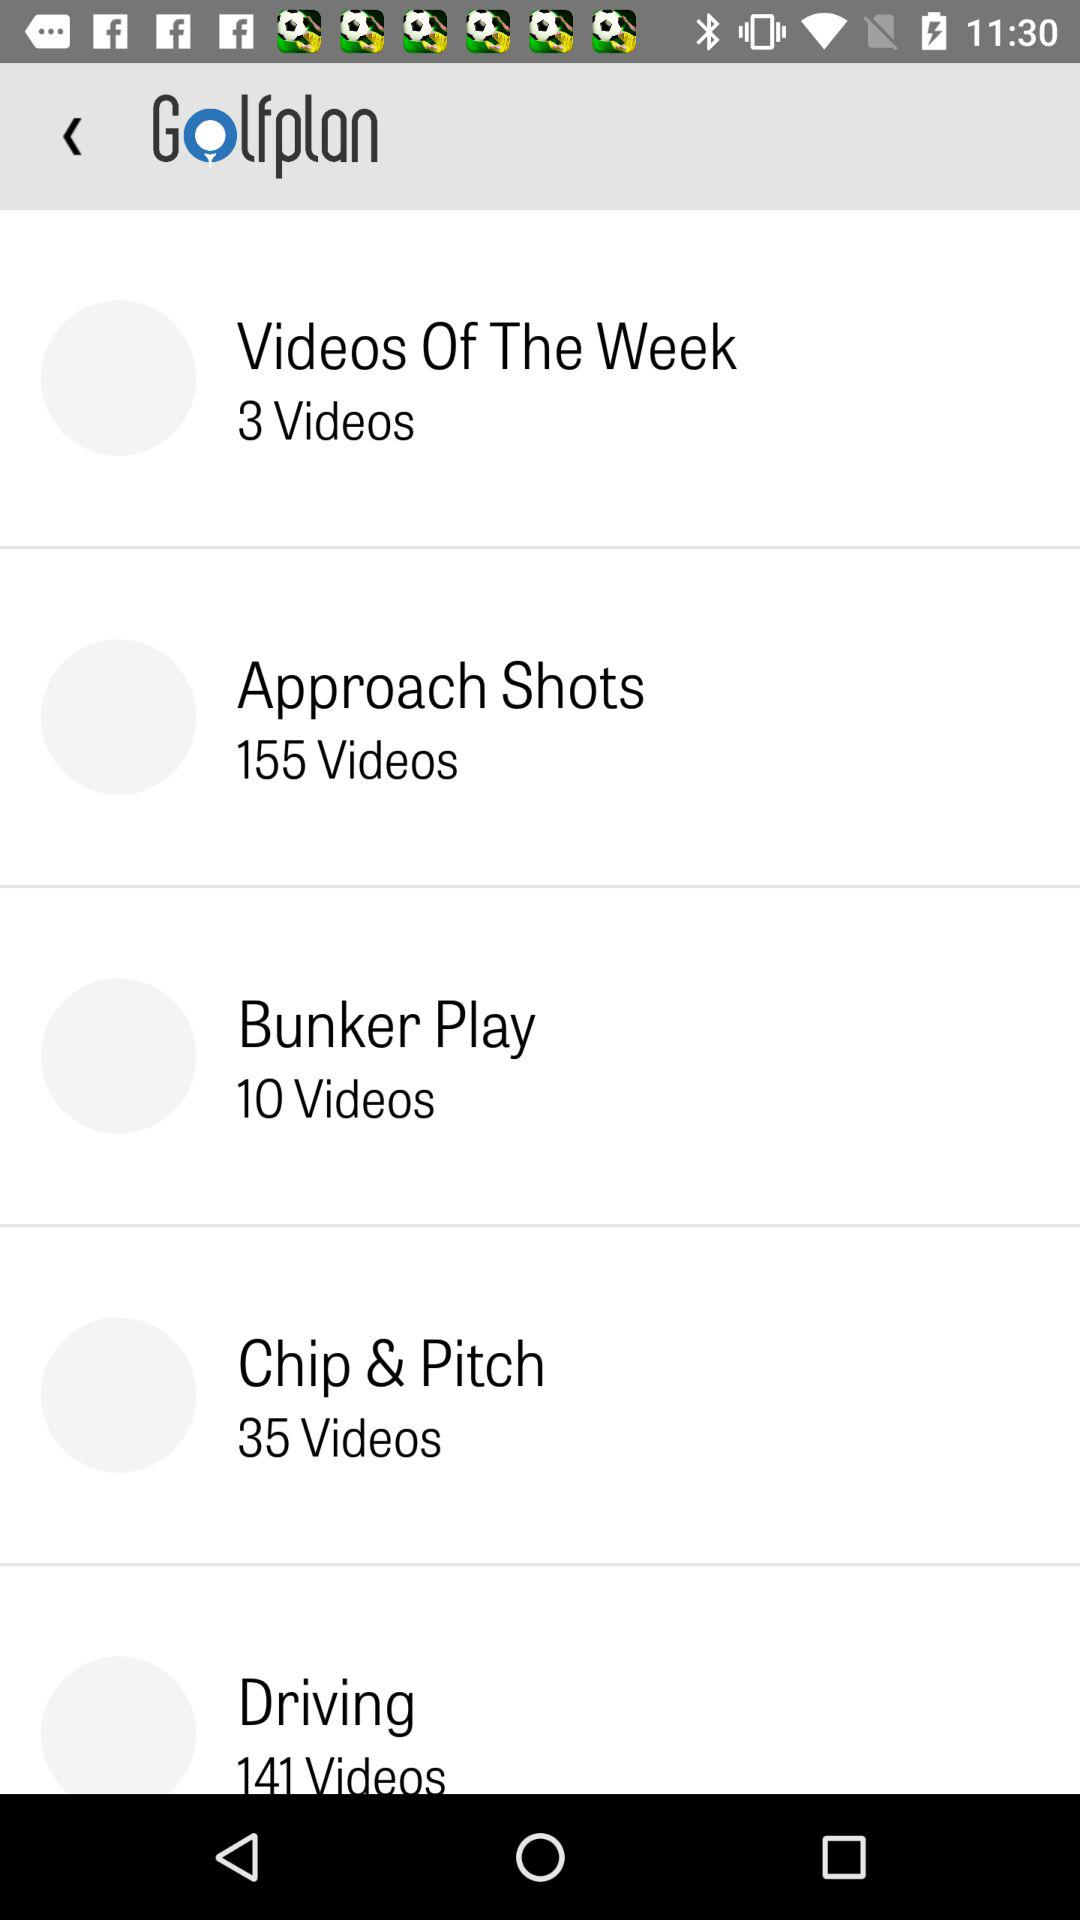What is the application name? The application name is "Golfplan". 